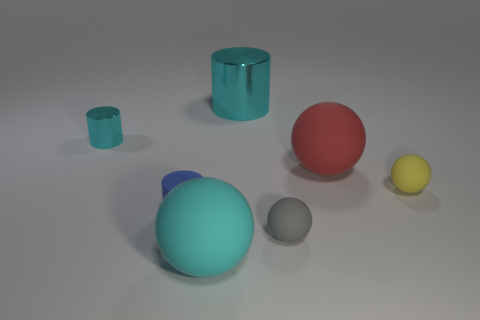Which object is the largest and which is the smallest in the scene? The largest object in the scene appears to be the blue sphere, while the smallest object seems to be the gray sphere. How can you differentiate them in terms of texture or material? The objects exhibit different sheens and shadows. The blue sphere and the small gray sphere both have a matte finish indicating a possible rubbery texture, whereas the turquoise and red objects have a shinier surface that may suggest a metallic or plastic material. 